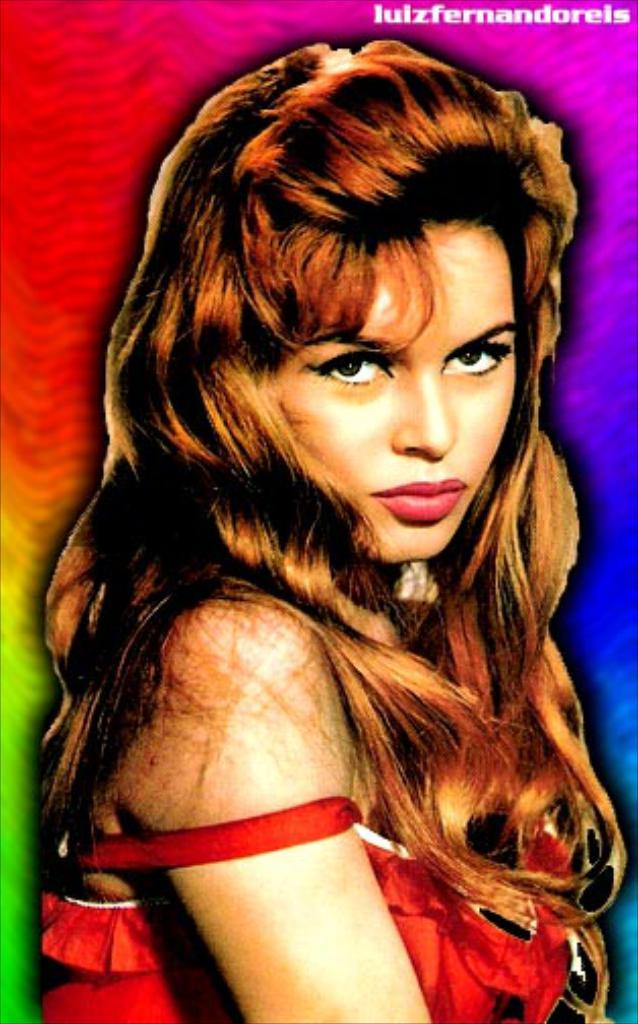Who is present in the image? There is a woman in the image. What else can be seen in the image besides the woman? There is text in the image, and the background is multicolored. Can you describe the appearance of the image? The image appears to be an edited photo. What type of chess piece can be seen in the image? There is no chess piece present in the image. What kind of beam is supporting the structure in the image? There is no structure or beam present in the image. 